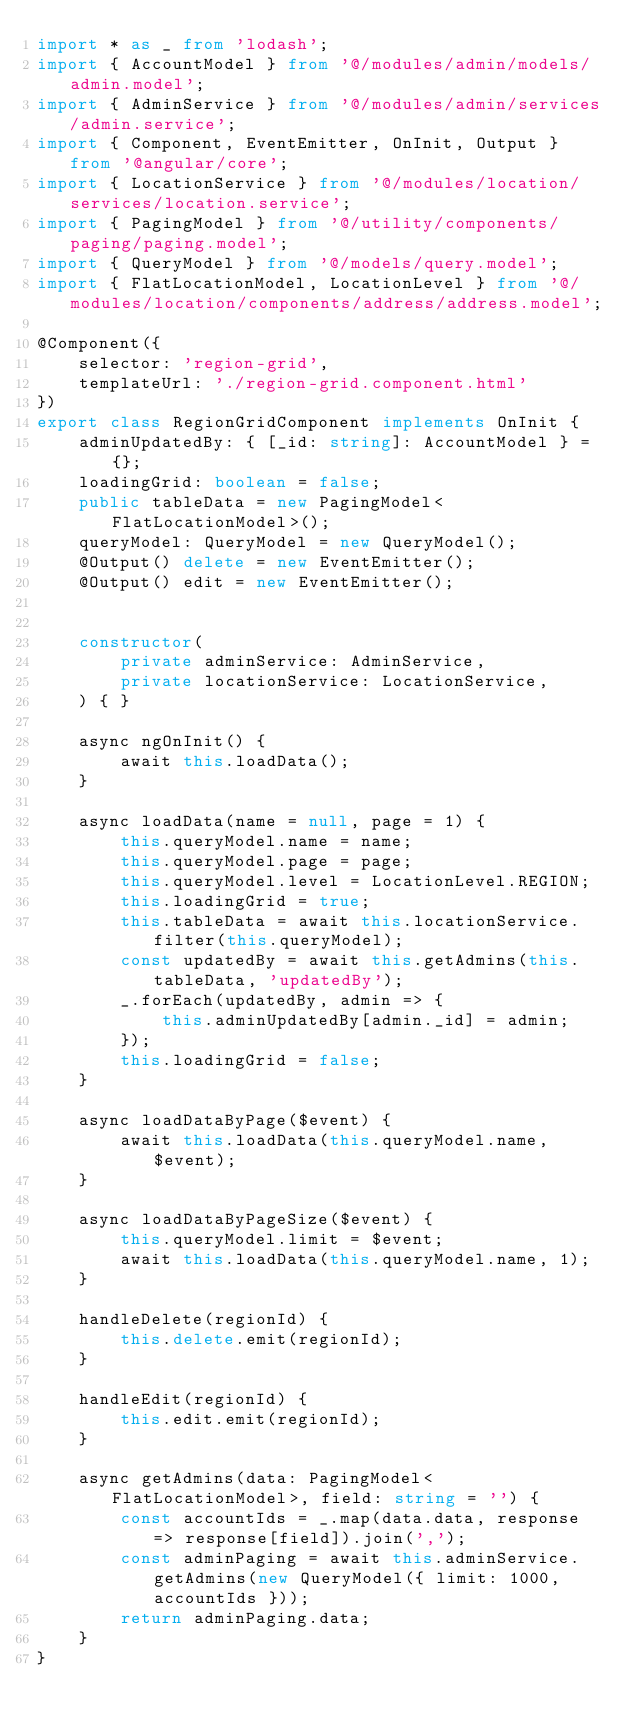<code> <loc_0><loc_0><loc_500><loc_500><_TypeScript_>import * as _ from 'lodash';
import { AccountModel } from '@/modules/admin/models/admin.model';
import { AdminService } from '@/modules/admin/services/admin.service';
import { Component, EventEmitter, OnInit, Output } from '@angular/core';
import { LocationService } from '@/modules/location/services/location.service';
import { PagingModel } from '@/utility/components/paging/paging.model';
import { QueryModel } from '@/models/query.model';
import { FlatLocationModel, LocationLevel } from '@/modules/location/components/address/address.model';

@Component({
    selector: 'region-grid',
    templateUrl: './region-grid.component.html'
})
export class RegionGridComponent implements OnInit {
    adminUpdatedBy: { [_id: string]: AccountModel } = {};
    loadingGrid: boolean = false;
    public tableData = new PagingModel<FlatLocationModel>();
    queryModel: QueryModel = new QueryModel();
    @Output() delete = new EventEmitter();
    @Output() edit = new EventEmitter();


    constructor(
        private adminService: AdminService,
        private locationService: LocationService,
    ) { }

    async ngOnInit() {
        await this.loadData();
    }

    async loadData(name = null, page = 1) {
        this.queryModel.name = name;
        this.queryModel.page = page;
        this.queryModel.level = LocationLevel.REGION;
        this.loadingGrid = true;
        this.tableData = await this.locationService.filter(this.queryModel);
        const updatedBy = await this.getAdmins(this.tableData, 'updatedBy');
        _.forEach(updatedBy, admin => {
            this.adminUpdatedBy[admin._id] = admin;
        });
        this.loadingGrid = false;
    }

    async loadDataByPage($event) {
        await this.loadData(this.queryModel.name, $event);
    }

    async loadDataByPageSize($event) {
        this.queryModel.limit = $event;
        await this.loadData(this.queryModel.name, 1);
    }

    handleDelete(regionId) {
        this.delete.emit(regionId);
    }

    handleEdit(regionId) {
        this.edit.emit(regionId);
    }

    async getAdmins(data: PagingModel<FlatLocationModel>, field: string = '') {
        const accountIds = _.map(data.data, response => response[field]).join(',');
        const adminPaging = await this.adminService.getAdmins(new QueryModel({ limit: 1000, accountIds }));
        return adminPaging.data;
    }
}
</code> 